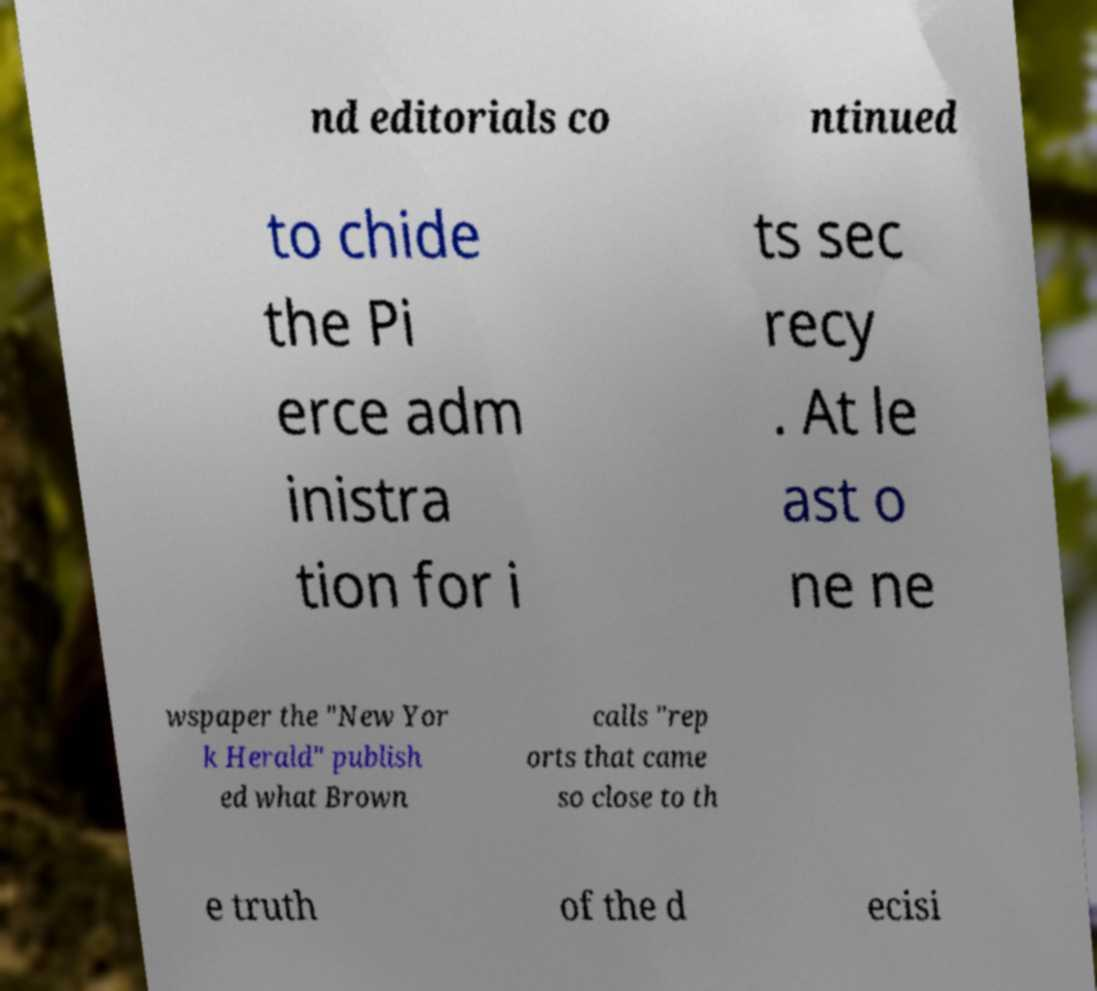Could you assist in decoding the text presented in this image and type it out clearly? nd editorials co ntinued to chide the Pi erce adm inistra tion for i ts sec recy . At le ast o ne ne wspaper the "New Yor k Herald" publish ed what Brown calls "rep orts that came so close to th e truth of the d ecisi 